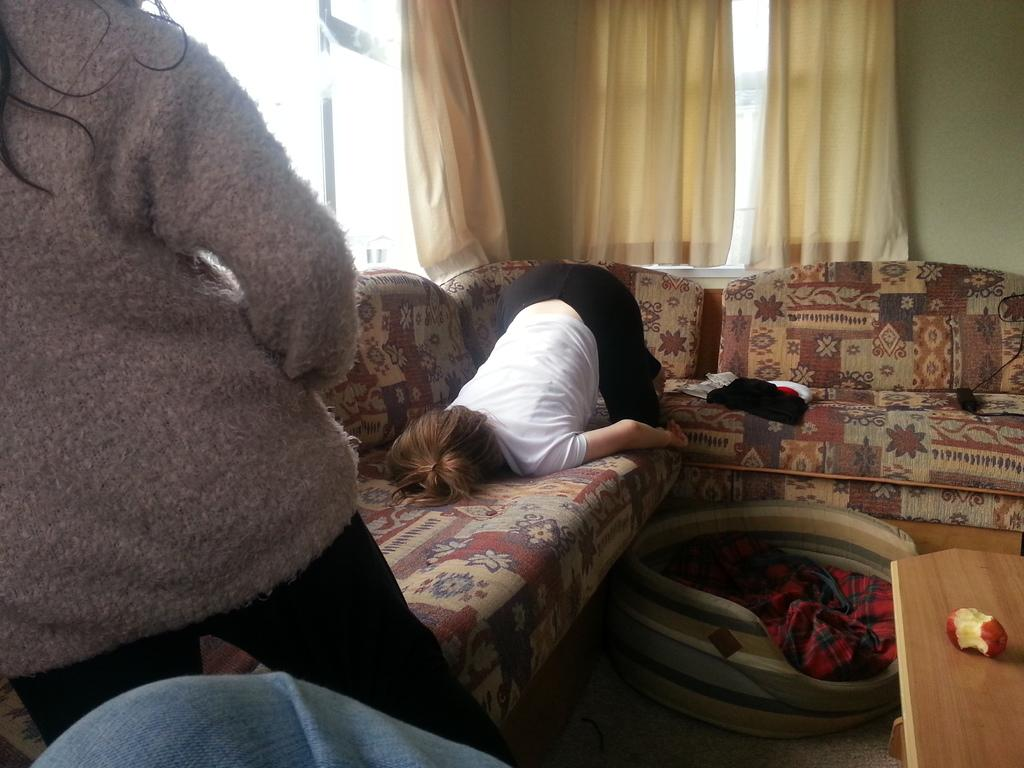How many people are present in the image? There are three people in the image. What type of furniture is visible in the image? There is a sofa and a table in the image. What is on the table in the image? There is an apple on the table. What can be seen in the background of the image? There are windows with curtains in the background of the image. What type of popcorn is being kicked around by the people in the image? There is no popcorn or kicking activity present in the image. 